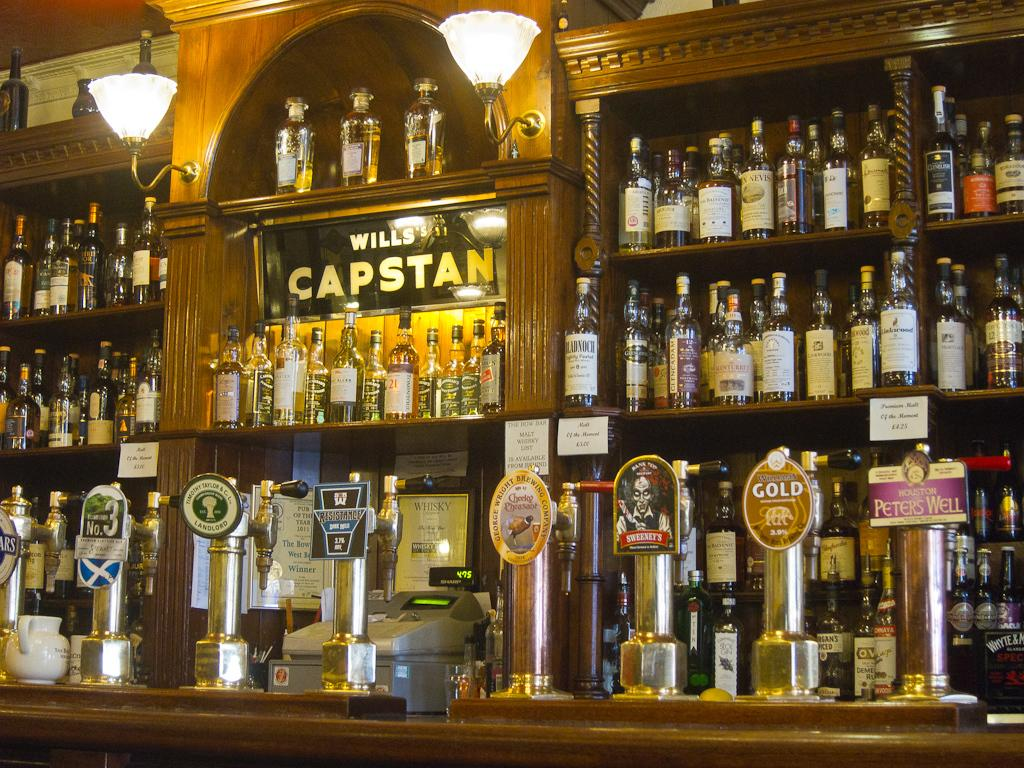<image>
Present a compact description of the photo's key features. A bar with dozens of bottles stacked around a Wills Capstan sign in the middle of it all. 